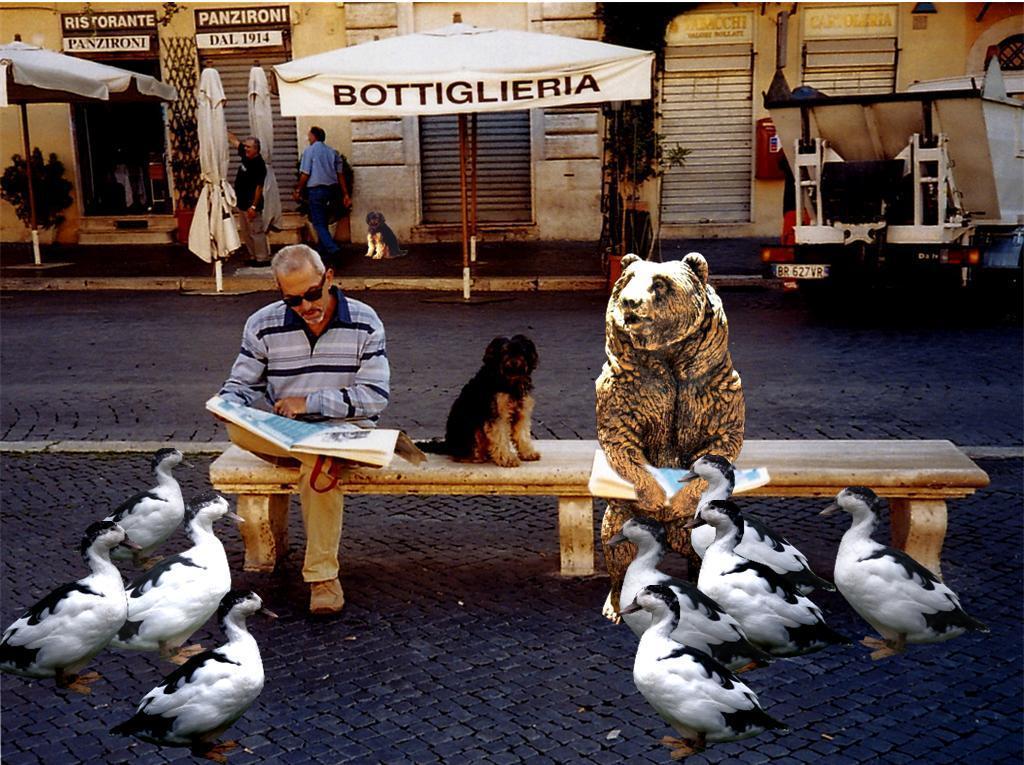Can you describe this image briefly? This is completely an outside view picture. Here we can see stores. This is umbrella in front of stores. We can see dog on the bench over here. Here we can see few birds on the road. On the bench we can see one man sitting and reading a newspaper. 